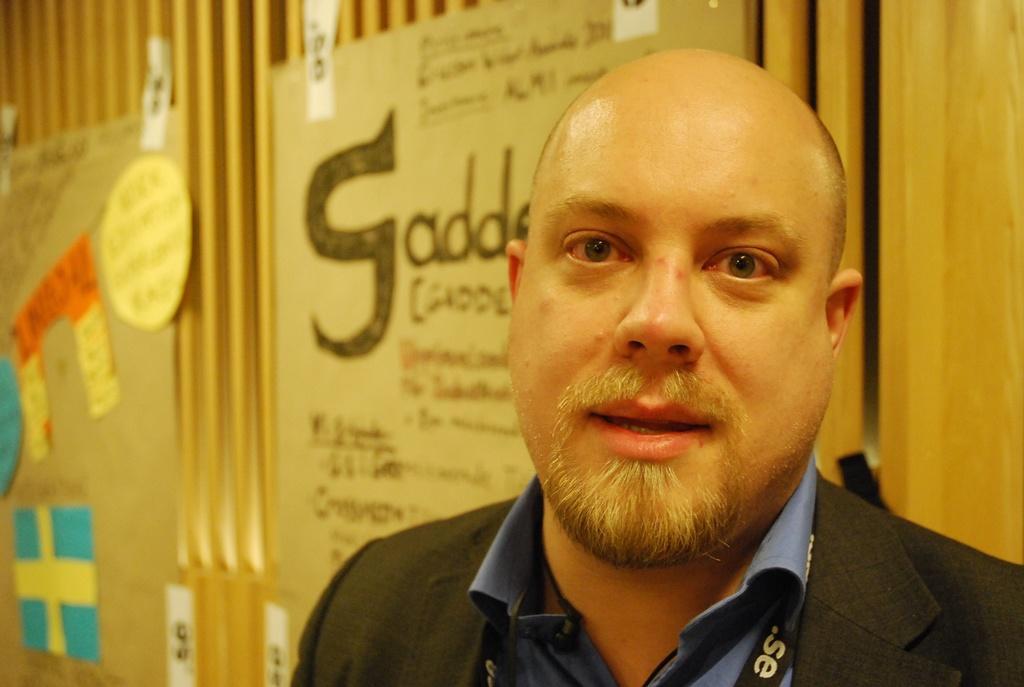In one or two sentences, can you explain what this image depicts? In this picture we can see a man, he wore a tag, in the background we can see few posters. 